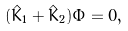<formula> <loc_0><loc_0><loc_500><loc_500>( \hat { K } _ { 1 } + \hat { K } _ { 2 } ) \Phi = 0 ,</formula> 